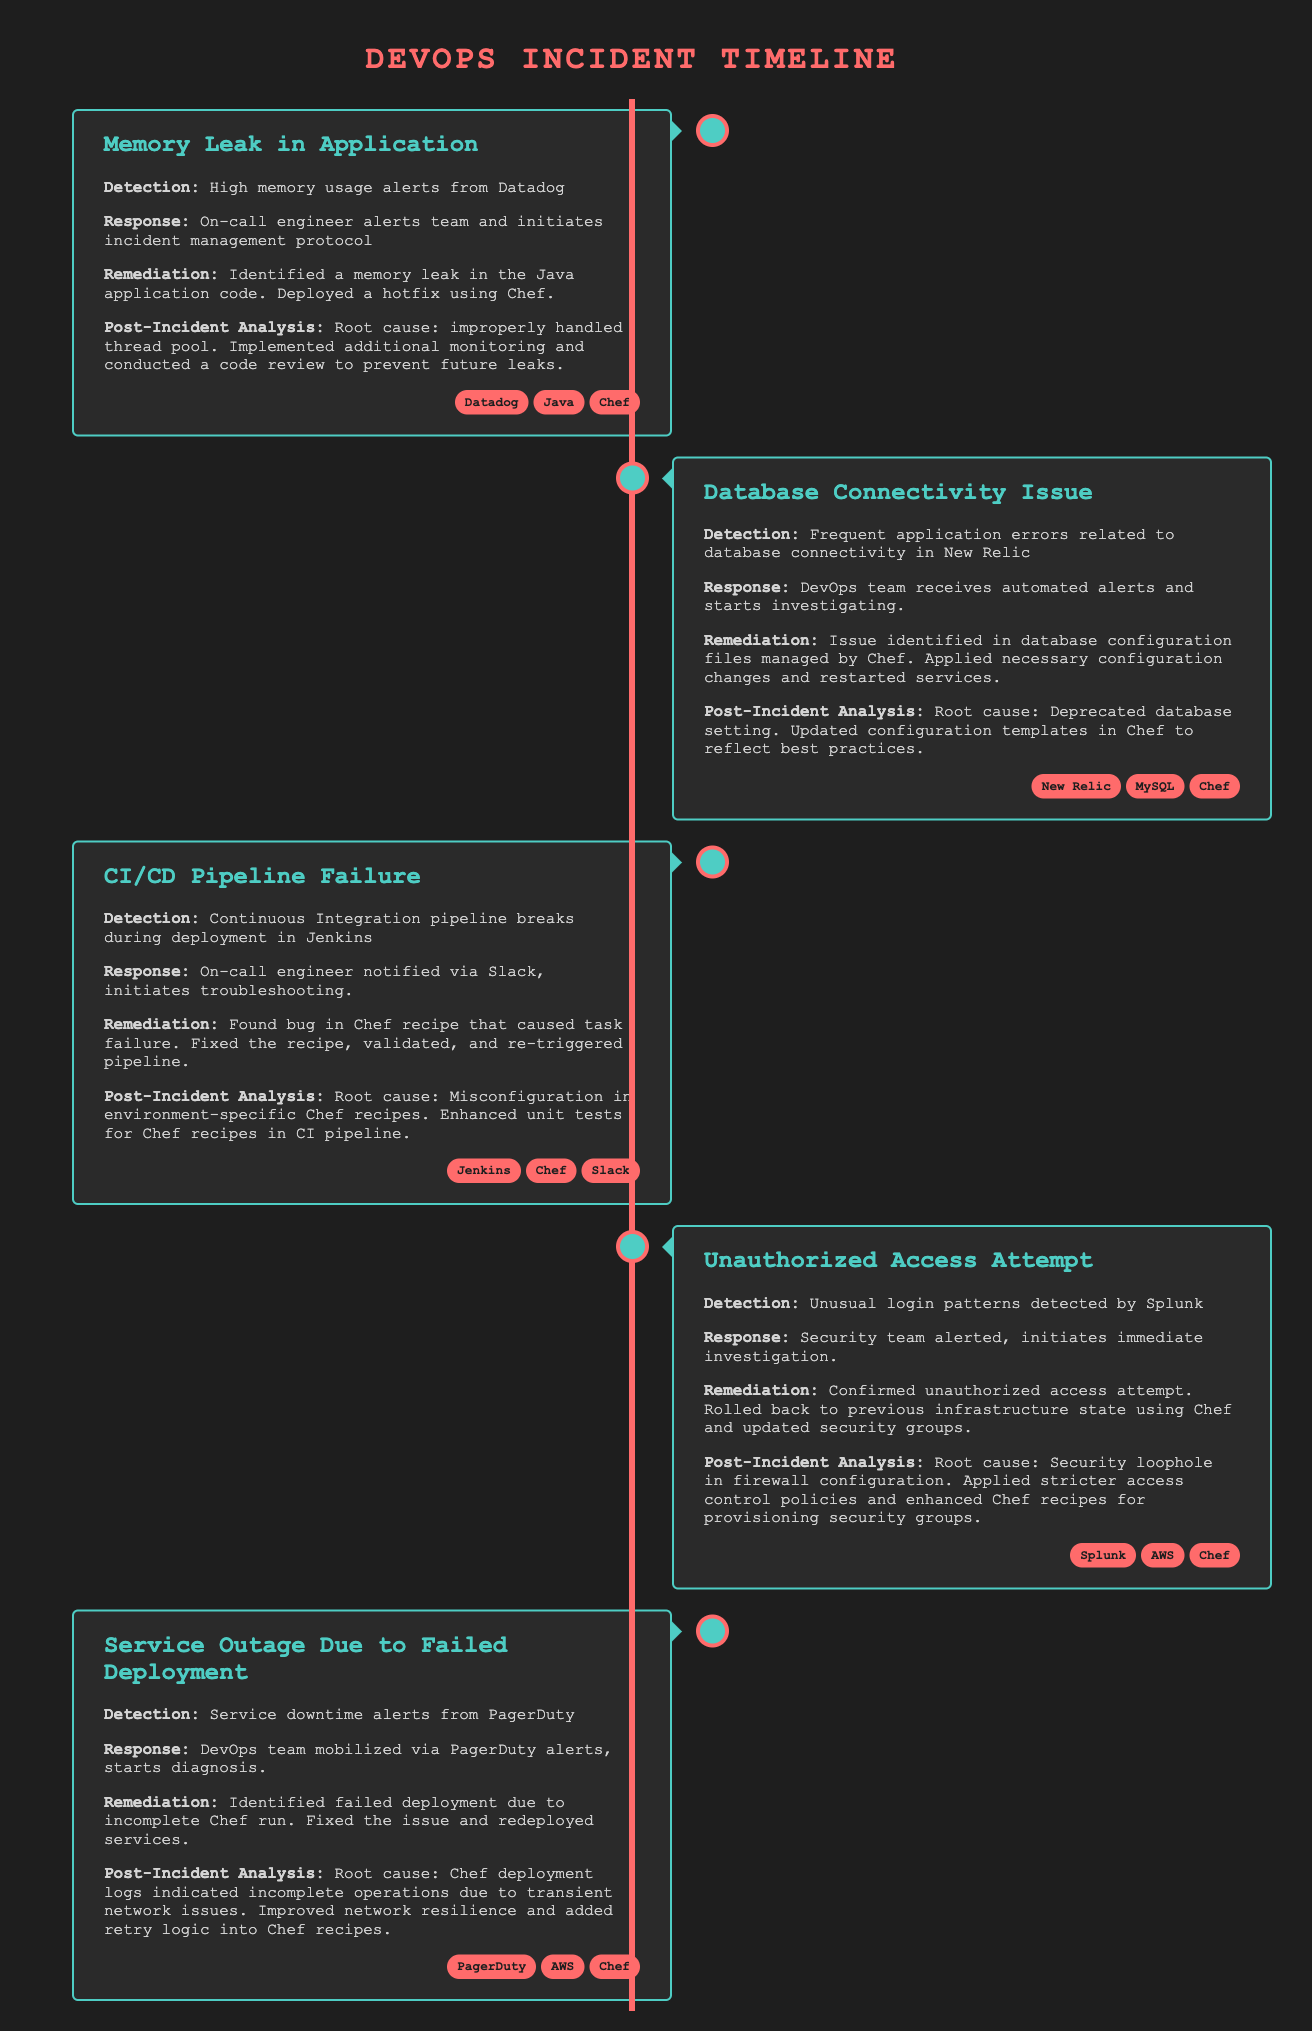What incident was detected by Datadog? The incident detected by Datadog was a memory leak in the application.
Answer: Memory Leak in Application What tool was used to manage the database configuration? The database configuration was managed by Chef.
Answer: Chef What caused the CI/CD pipeline failure? The cause of the CI/CD pipeline failure was a bug in the Chef recipe.
Answer: Bug in Chef recipe What monitoring tool detected the unauthorized access attempt? The unusual login patterns were detected by Splunk.
Answer: Splunk What alerting service notified the DevOps team about the service outage? The service downtime alerts were from PagerDuty.
Answer: PagerDuty What was the root cause of the database connectivity issue? The root cause was a deprecated database setting.
Answer: Deprecated database setting How was the memory leak resolved? The memory leak was resolved by deploying a hotfix using Chef.
Answer: Hotfix using Chef Which incident had a response initiated via Slack? The CI/CD pipeline failure had a response initiated via Slack.
Answer: CI/CD Pipeline Failure What action was taken after the unauthorized access attempt? The action taken was rolling back to a previous infrastructure state using Chef.
Answer: Rolled back using Chef 